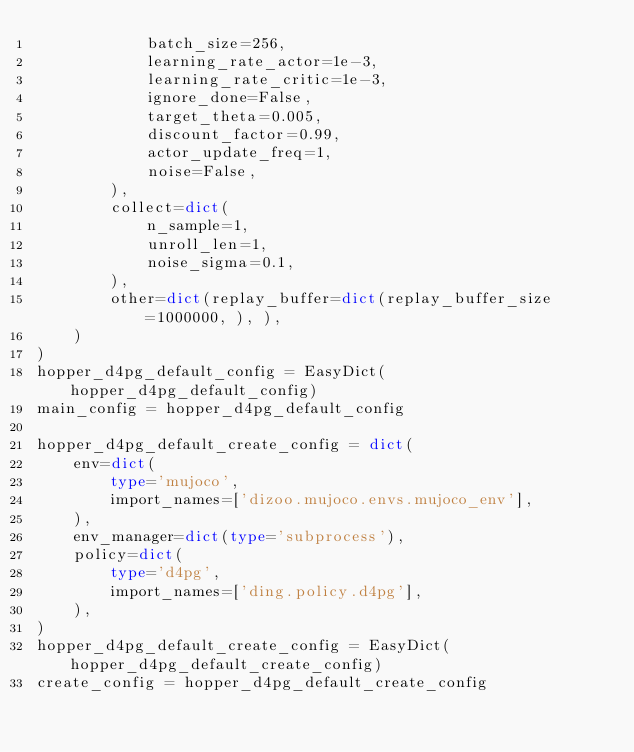Convert code to text. <code><loc_0><loc_0><loc_500><loc_500><_Python_>            batch_size=256,
            learning_rate_actor=1e-3,
            learning_rate_critic=1e-3,
            ignore_done=False,
            target_theta=0.005,
            discount_factor=0.99,
            actor_update_freq=1,
            noise=False,
        ),
        collect=dict(
            n_sample=1,
            unroll_len=1,
            noise_sigma=0.1,
        ),
        other=dict(replay_buffer=dict(replay_buffer_size=1000000, ), ),
    )
)
hopper_d4pg_default_config = EasyDict(hopper_d4pg_default_config)
main_config = hopper_d4pg_default_config

hopper_d4pg_default_create_config = dict(
    env=dict(
        type='mujoco',
        import_names=['dizoo.mujoco.envs.mujoco_env'],
    ),
    env_manager=dict(type='subprocess'),
    policy=dict(
        type='d4pg',
        import_names=['ding.policy.d4pg'],
    ),
)
hopper_d4pg_default_create_config = EasyDict(hopper_d4pg_default_create_config)
create_config = hopper_d4pg_default_create_config
</code> 